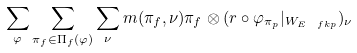Convert formula to latex. <formula><loc_0><loc_0><loc_500><loc_500>\sum _ { \varphi } \sum _ { \pi _ { f } \in \Pi _ { f } ( \varphi ) } \sum _ { \nu } m ( \pi _ { f } , \nu ) \pi _ { f } \otimes ( r \circ \varphi _ { \pi _ { p } } | _ { W _ { E _ { \ } f k p } } ) _ { \nu }</formula> 